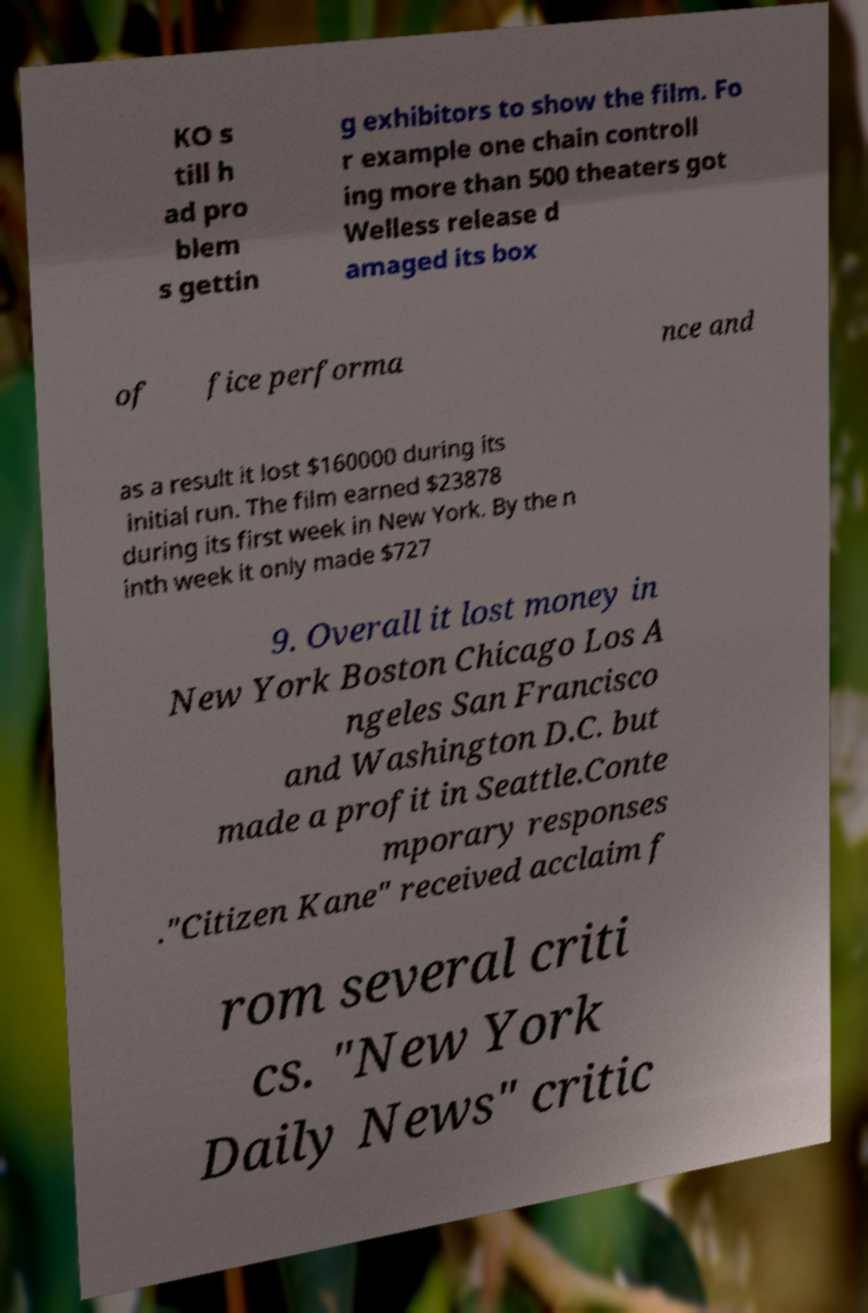For documentation purposes, I need the text within this image transcribed. Could you provide that? KO s till h ad pro blem s gettin g exhibitors to show the film. Fo r example one chain controll ing more than 500 theaters got Welless release d amaged its box of fice performa nce and as a result it lost $160000 during its initial run. The film earned $23878 during its first week in New York. By the n inth week it only made $727 9. Overall it lost money in New York Boston Chicago Los A ngeles San Francisco and Washington D.C. but made a profit in Seattle.Conte mporary responses ."Citizen Kane" received acclaim f rom several criti cs. "New York Daily News" critic 